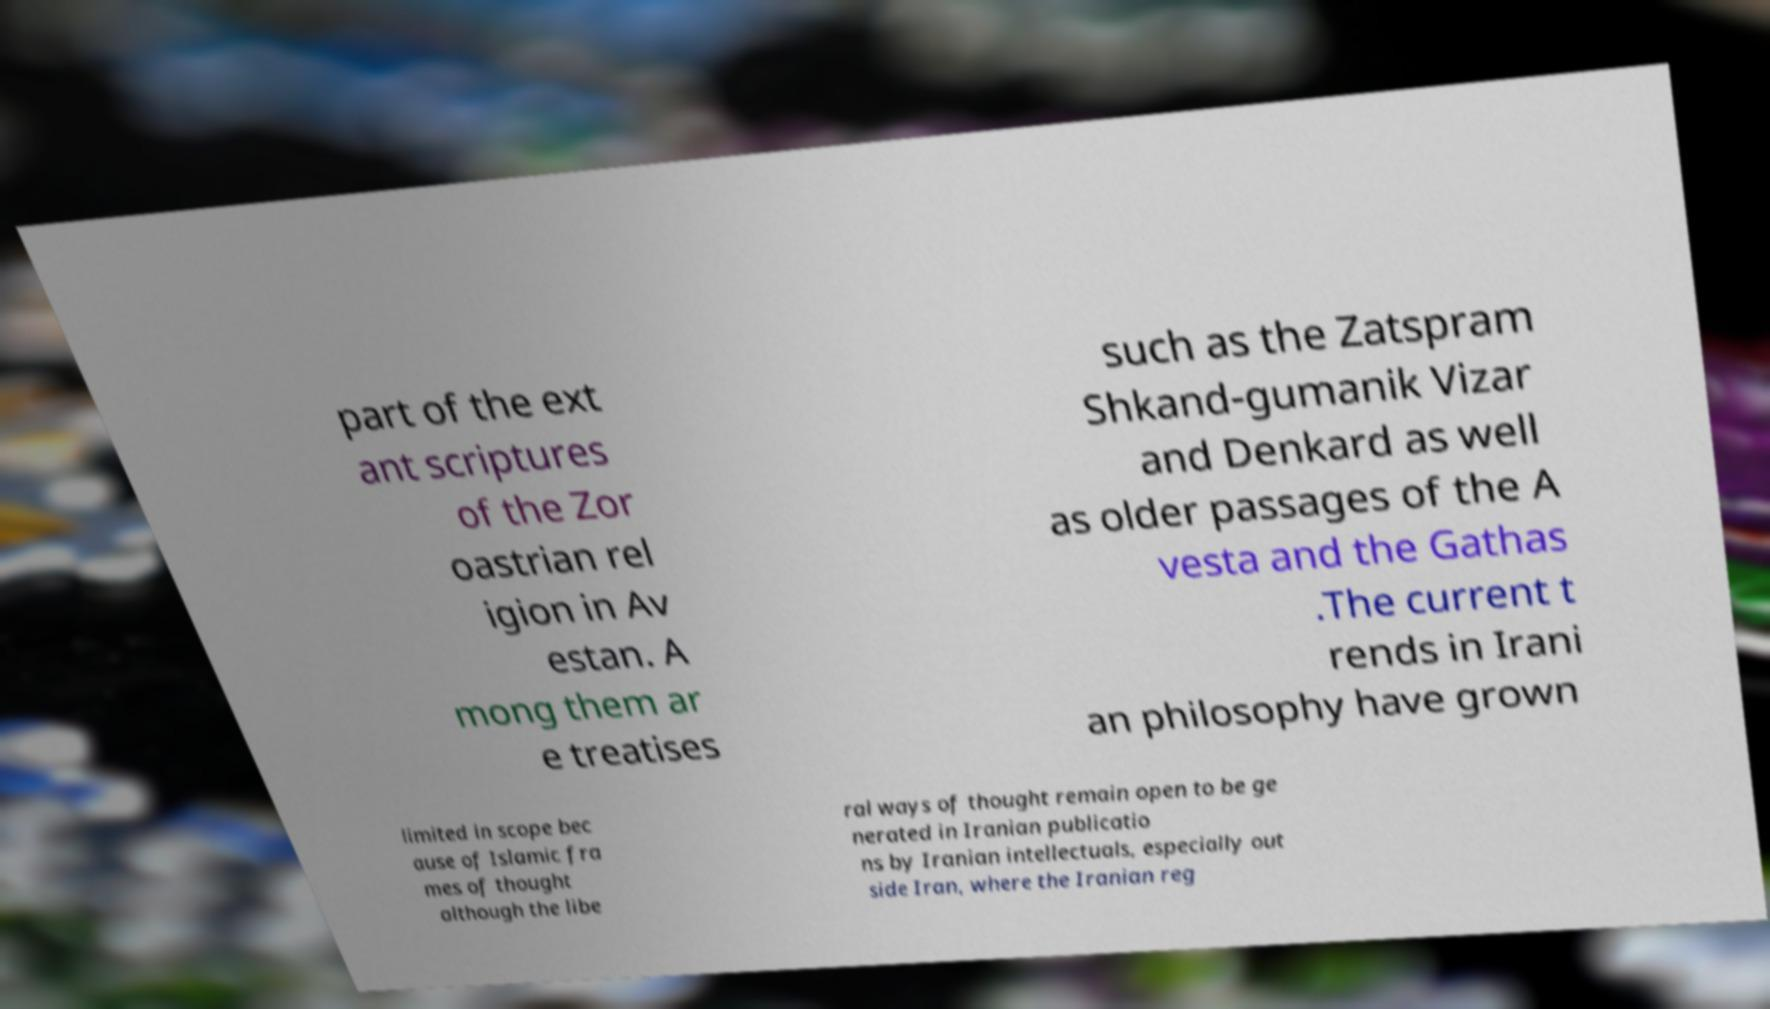I need the written content from this picture converted into text. Can you do that? part of the ext ant scriptures of the Zor oastrian rel igion in Av estan. A mong them ar e treatises such as the Zatspram Shkand-gumanik Vizar and Denkard as well as older passages of the A vesta and the Gathas .The current t rends in Irani an philosophy have grown limited in scope bec ause of Islamic fra mes of thought although the libe ral ways of thought remain open to be ge nerated in Iranian publicatio ns by Iranian intellectuals, especially out side Iran, where the Iranian reg 